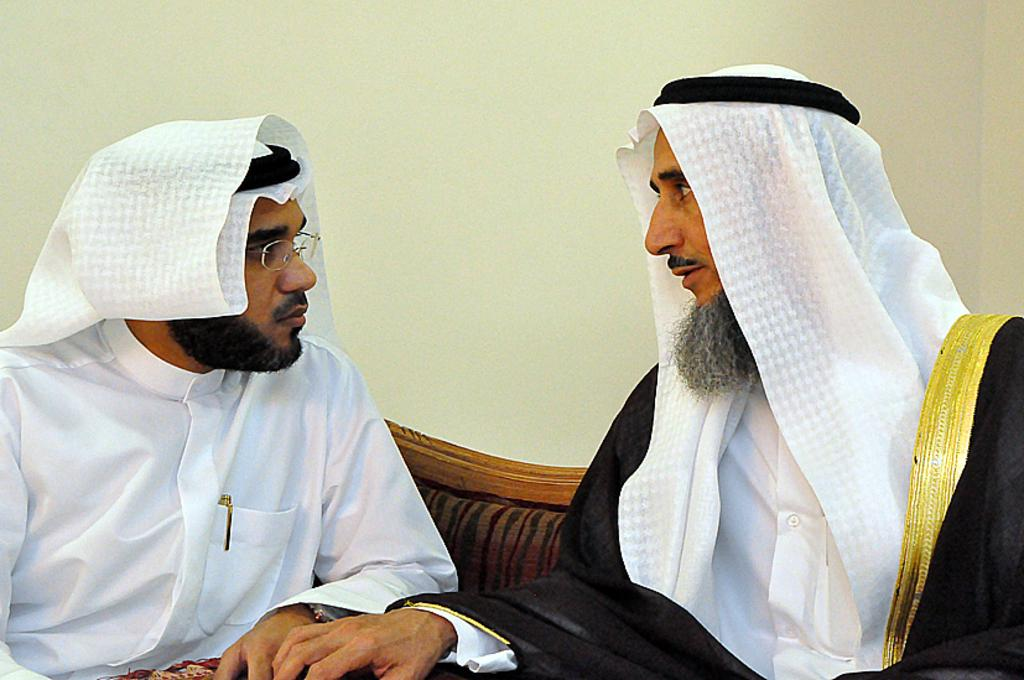Who is present in the image? There are men in the image. What are the men doing in the image? The men are seated on a sofa. What are the men wearing on their heads? The men are wearing clothes on their heads. What can be seen in the background of the image? There is a wall visible in the image. What type of wrench is being used by the men in the image? There is no wrench present in the image; the men are wearing clothes on their heads while seated on a sofa. 